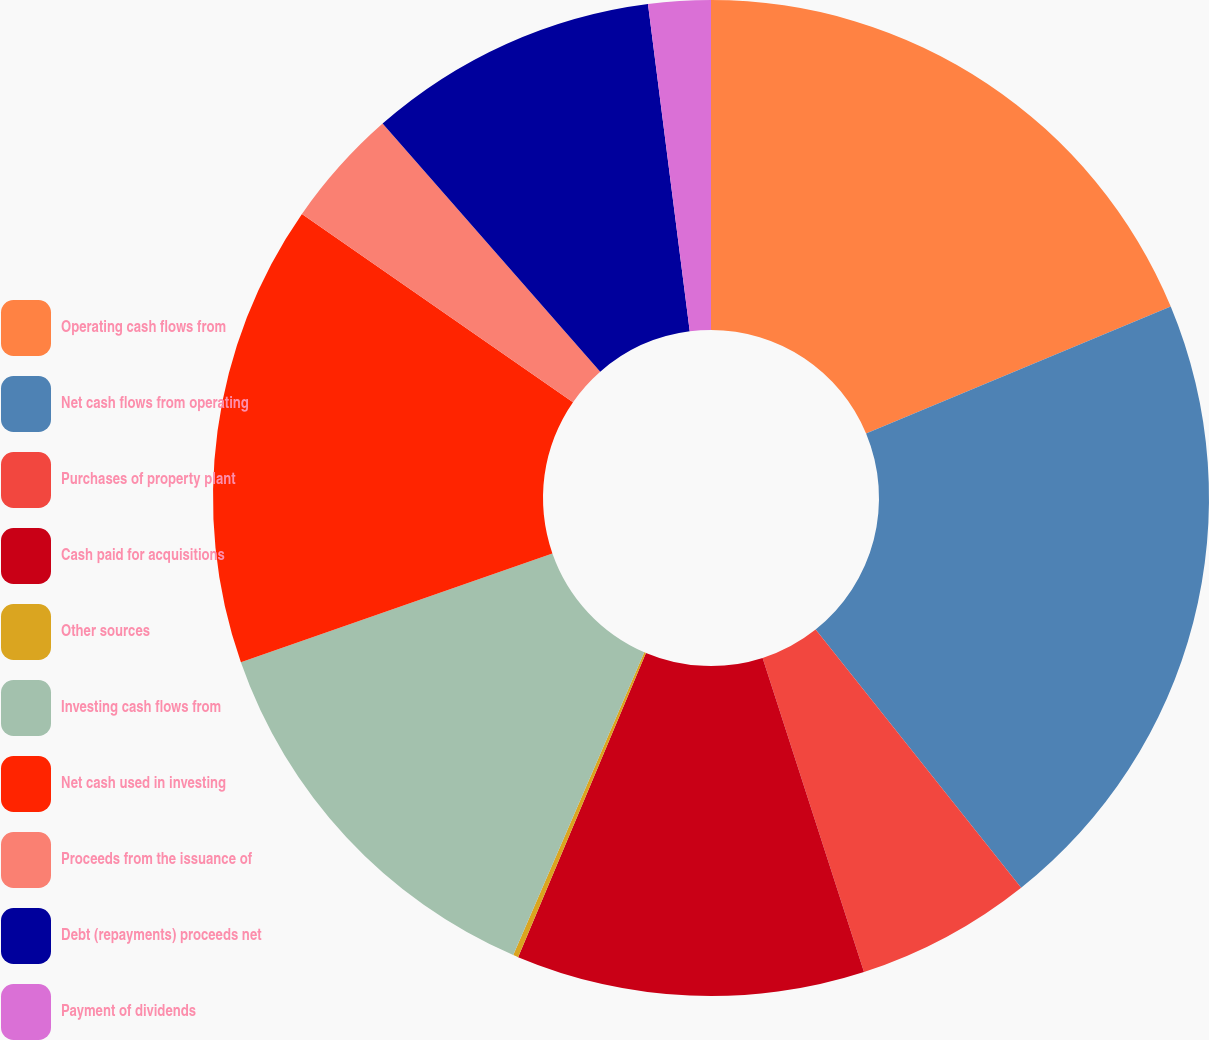Convert chart. <chart><loc_0><loc_0><loc_500><loc_500><pie_chart><fcel>Operating cash flows from<fcel>Net cash flows from operating<fcel>Purchases of property plant<fcel>Cash paid for acquisitions<fcel>Other sources<fcel>Investing cash flows from<fcel>Net cash used in investing<fcel>Proceeds from the issuance of<fcel>Debt (repayments) proceeds net<fcel>Payment of dividends<nl><fcel>18.72%<fcel>20.58%<fcel>5.73%<fcel>11.3%<fcel>0.17%<fcel>13.15%<fcel>15.01%<fcel>3.88%<fcel>9.44%<fcel>2.02%<nl></chart> 